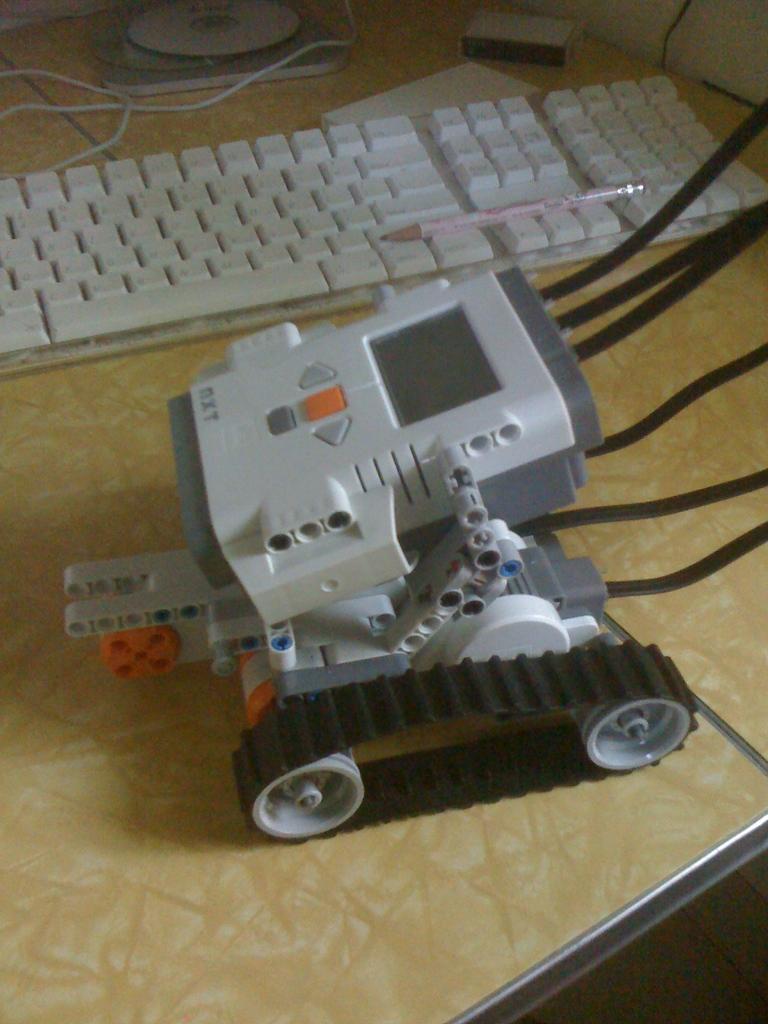How would you summarize this image in a sentence or two? In this picture we can see a robot vehicle, a pencil on a keyboard and other objects on the table. 